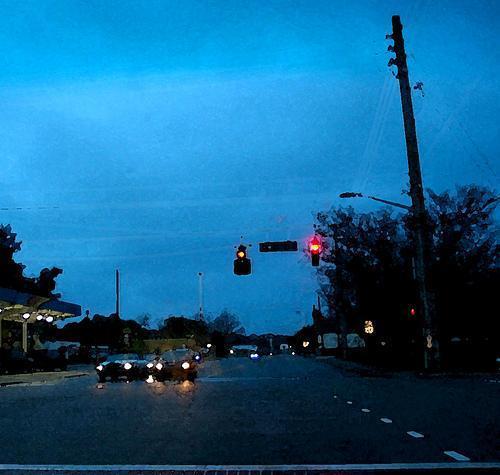How many traffic lights are shown?
Give a very brief answer. 2. How many red lights are there?
Give a very brief answer. 2. How many green lights are there?
Give a very brief answer. 0. How many keyboards are there?
Give a very brief answer. 0. 